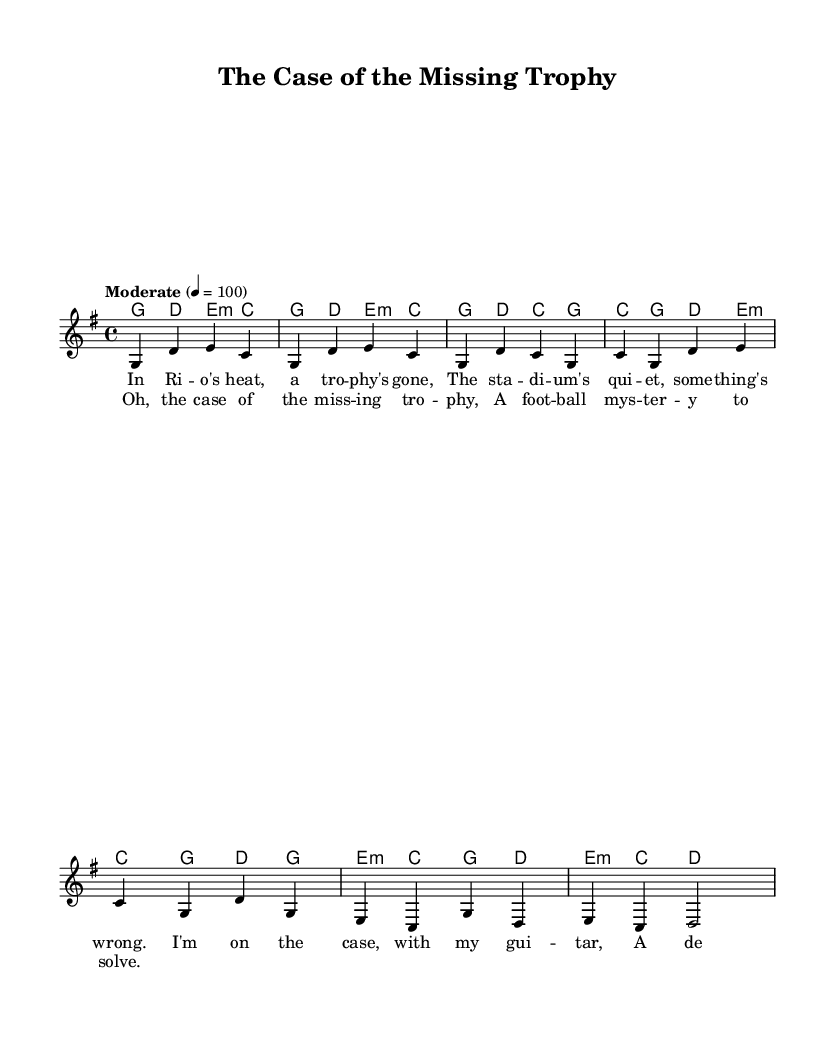What is the key signature of this music? The key signature is G major, which has one sharp (F#). The key signature can be identified at the beginning of the score where the sharps or flats are indicated.
Answer: G major What is the time signature of the music? The time signature is 4/4, as indicated in the score. This means there are four beats in each measure, and the quarter note gets one beat.
Answer: 4/4 What is the tempo marking for this piece? The tempo marking is "Moderate" with a metronome marking of 100 beats per minute. This information is given at the beginning of the score.
Answer: Moderate 100 How many measures are in the verse? The verse consists of four measures, as can be counted directly from the score section that outlines the verse lyrics and music.
Answer: Four What lyrical theme is evident in the chorus? The chorus reveals a theme of mystery related to a missing trophy, which is central to the narrative. This can be concluded by examining the lyrics provided in the chorus.
Answer: Missing trophy What chord is played in the first measure of the verse? The chord played in the first measure of the verse is G major, which can be found in the chord section aligned with the melody of the first measure.
Answer: G major 